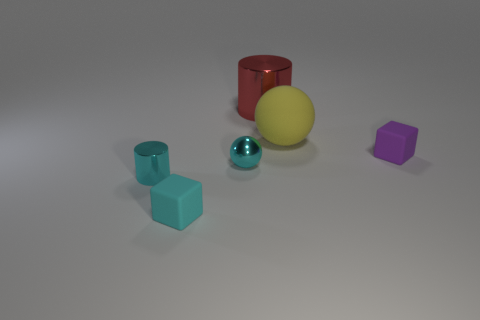Subtract all cyan spheres. How many spheres are left? 1 Add 1 small brown cylinders. How many objects exist? 7 Subtract all yellow things. Subtract all small objects. How many objects are left? 1 Add 6 tiny cylinders. How many tiny cylinders are left? 7 Add 6 cyan metal cylinders. How many cyan metal cylinders exist? 7 Subtract 1 cyan balls. How many objects are left? 5 